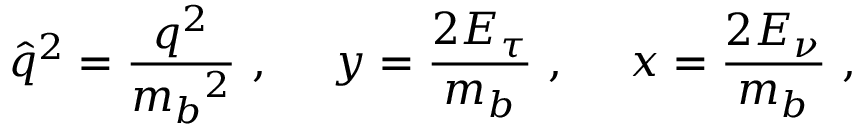Convert formula to latex. <formula><loc_0><loc_0><loc_500><loc_500>\hat { q } ^ { 2 } = \frac { q ^ { 2 } } { { m _ { b } } ^ { 2 } } \, , \, y = \frac { 2 E _ { \tau } } { m _ { b } } \, , \, x = \frac { 2 E _ { \nu } } { m _ { b } } \, ,</formula> 